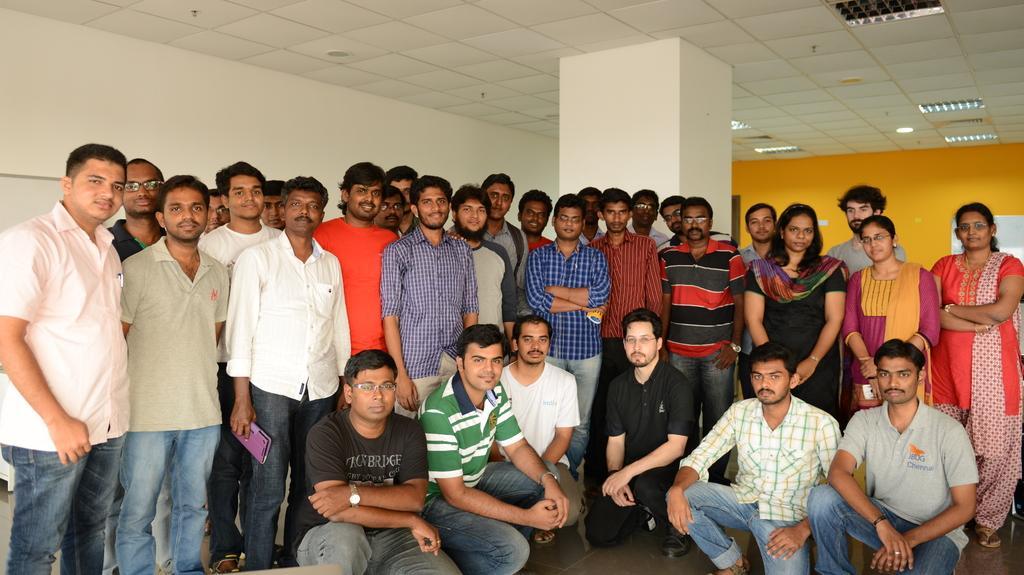Could you give a brief overview of what you see in this image? In this picture we can see a group of people from left to right. We can see a person holding a violet color object in his hand. There is a pillar, wall and some lights on top. 